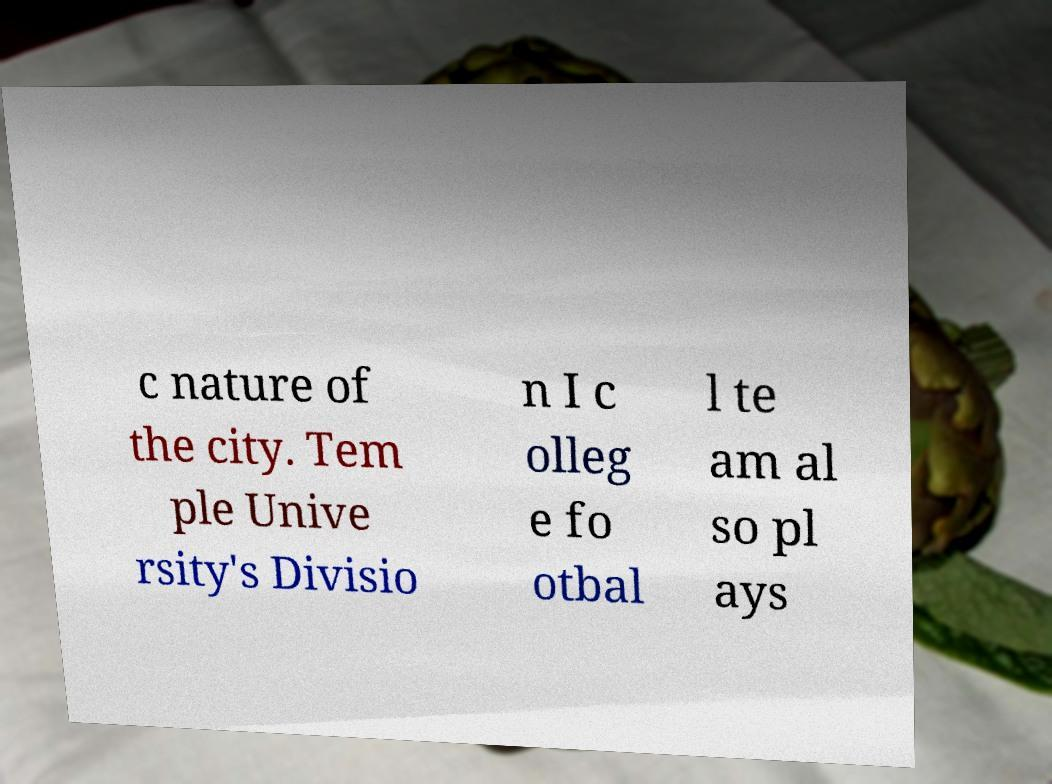I need the written content from this picture converted into text. Can you do that? c nature of the city. Tem ple Unive rsity's Divisio n I c olleg e fo otbal l te am al so pl ays 